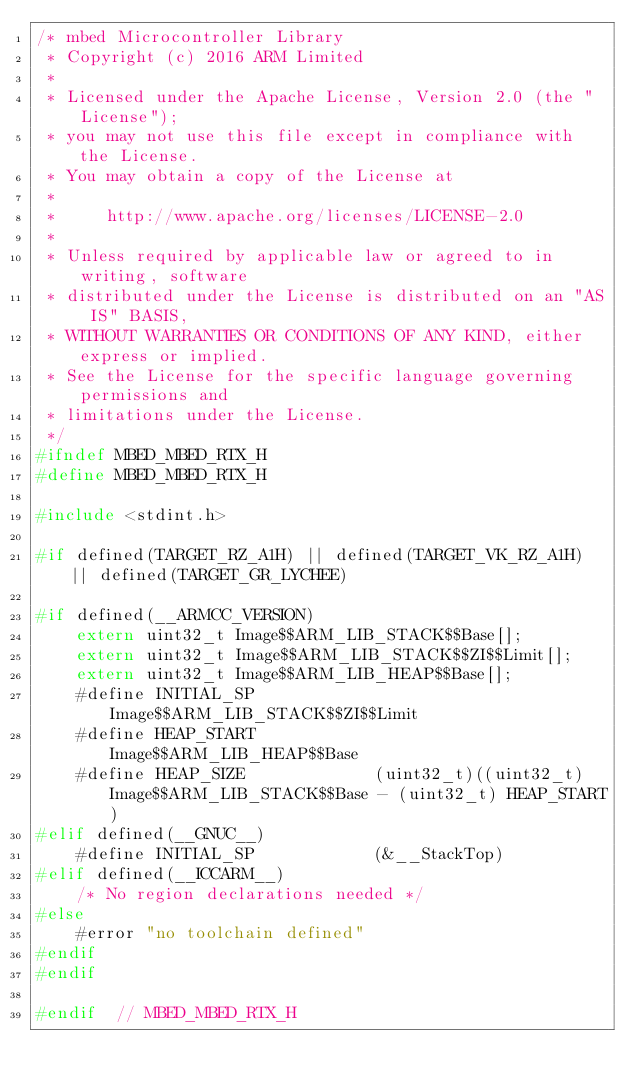Convert code to text. <code><loc_0><loc_0><loc_500><loc_500><_C_>/* mbed Microcontroller Library
 * Copyright (c) 2016 ARM Limited
 *
 * Licensed under the Apache License, Version 2.0 (the "License");
 * you may not use this file except in compliance with the License.
 * You may obtain a copy of the License at
 *
 *     http://www.apache.org/licenses/LICENSE-2.0
 *
 * Unless required by applicable law or agreed to in writing, software
 * distributed under the License is distributed on an "AS IS" BASIS,
 * WITHOUT WARRANTIES OR CONDITIONS OF ANY KIND, either express or implied.
 * See the License for the specific language governing permissions and
 * limitations under the License.
 */
#ifndef MBED_MBED_RTX_H
#define MBED_MBED_RTX_H

#include <stdint.h>

#if defined(TARGET_RZ_A1H) || defined(TARGET_VK_RZ_A1H) || defined(TARGET_GR_LYCHEE)

#if defined(__ARMCC_VERSION)
    extern uint32_t Image$$ARM_LIB_STACK$$Base[];
    extern uint32_t Image$$ARM_LIB_STACK$$ZI$$Limit[];
    extern uint32_t Image$$ARM_LIB_HEAP$$Base[];
    #define INITIAL_SP            Image$$ARM_LIB_STACK$$ZI$$Limit
    #define HEAP_START            Image$$ARM_LIB_HEAP$$Base
    #define HEAP_SIZE             (uint32_t)((uint32_t) Image$$ARM_LIB_STACK$$Base - (uint32_t) HEAP_START)
#elif defined(__GNUC__)
    #define INITIAL_SP            (&__StackTop)
#elif defined(__ICCARM__)
    /* No region declarations needed */
#else
    #error "no toolchain defined"
#endif
#endif

#endif  // MBED_MBED_RTX_H
</code> 